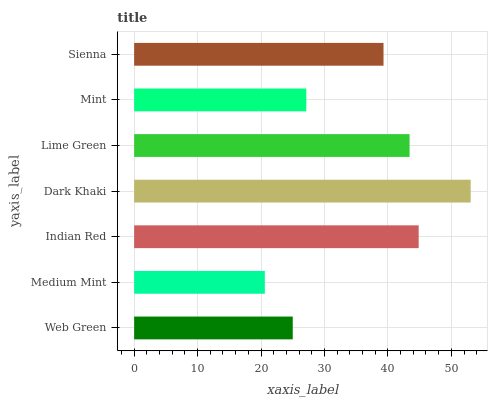Is Medium Mint the minimum?
Answer yes or no. Yes. Is Dark Khaki the maximum?
Answer yes or no. Yes. Is Indian Red the minimum?
Answer yes or no. No. Is Indian Red the maximum?
Answer yes or no. No. Is Indian Red greater than Medium Mint?
Answer yes or no. Yes. Is Medium Mint less than Indian Red?
Answer yes or no. Yes. Is Medium Mint greater than Indian Red?
Answer yes or no. No. Is Indian Red less than Medium Mint?
Answer yes or no. No. Is Sienna the high median?
Answer yes or no. Yes. Is Sienna the low median?
Answer yes or no. Yes. Is Medium Mint the high median?
Answer yes or no. No. Is Lime Green the low median?
Answer yes or no. No. 